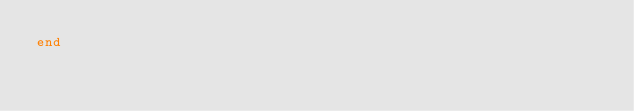<code> <loc_0><loc_0><loc_500><loc_500><_Ruby_>end
</code> 